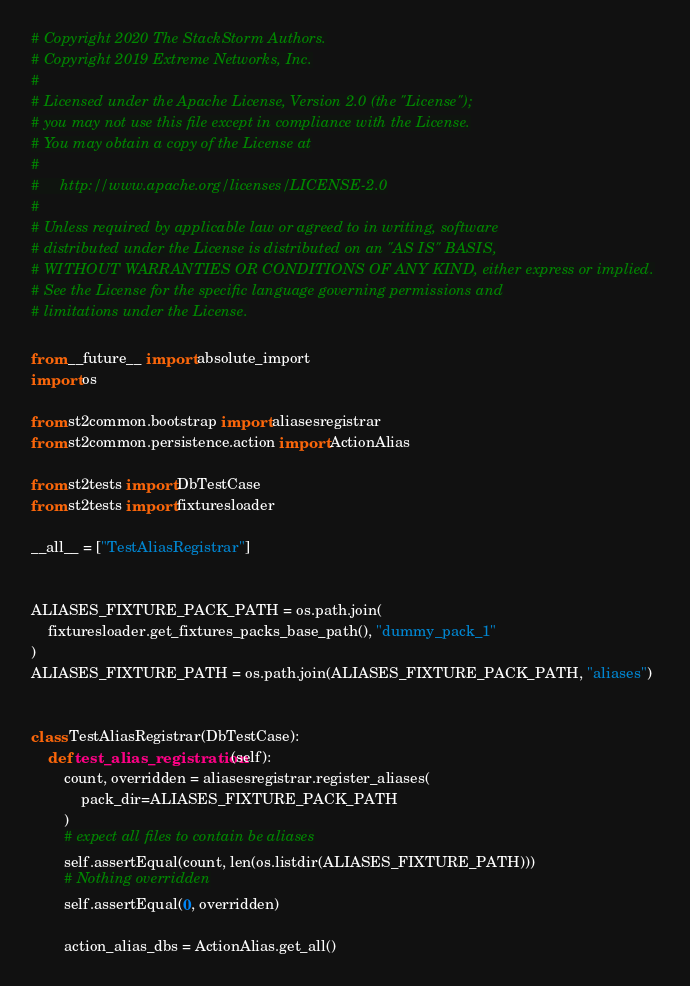Convert code to text. <code><loc_0><loc_0><loc_500><loc_500><_Python_># Copyright 2020 The StackStorm Authors.
# Copyright 2019 Extreme Networks, Inc.
#
# Licensed under the Apache License, Version 2.0 (the "License");
# you may not use this file except in compliance with the License.
# You may obtain a copy of the License at
#
#     http://www.apache.org/licenses/LICENSE-2.0
#
# Unless required by applicable law or agreed to in writing, software
# distributed under the License is distributed on an "AS IS" BASIS,
# WITHOUT WARRANTIES OR CONDITIONS OF ANY KIND, either express or implied.
# See the License for the specific language governing permissions and
# limitations under the License.

from __future__ import absolute_import
import os

from st2common.bootstrap import aliasesregistrar
from st2common.persistence.action import ActionAlias

from st2tests import DbTestCase
from st2tests import fixturesloader

__all__ = ["TestAliasRegistrar"]


ALIASES_FIXTURE_PACK_PATH = os.path.join(
    fixturesloader.get_fixtures_packs_base_path(), "dummy_pack_1"
)
ALIASES_FIXTURE_PATH = os.path.join(ALIASES_FIXTURE_PACK_PATH, "aliases")


class TestAliasRegistrar(DbTestCase):
    def test_alias_registration(self):
        count, overridden = aliasesregistrar.register_aliases(
            pack_dir=ALIASES_FIXTURE_PACK_PATH
        )
        # expect all files to contain be aliases
        self.assertEqual(count, len(os.listdir(ALIASES_FIXTURE_PATH)))
        # Nothing overridden
        self.assertEqual(0, overridden)

        action_alias_dbs = ActionAlias.get_all()</code> 